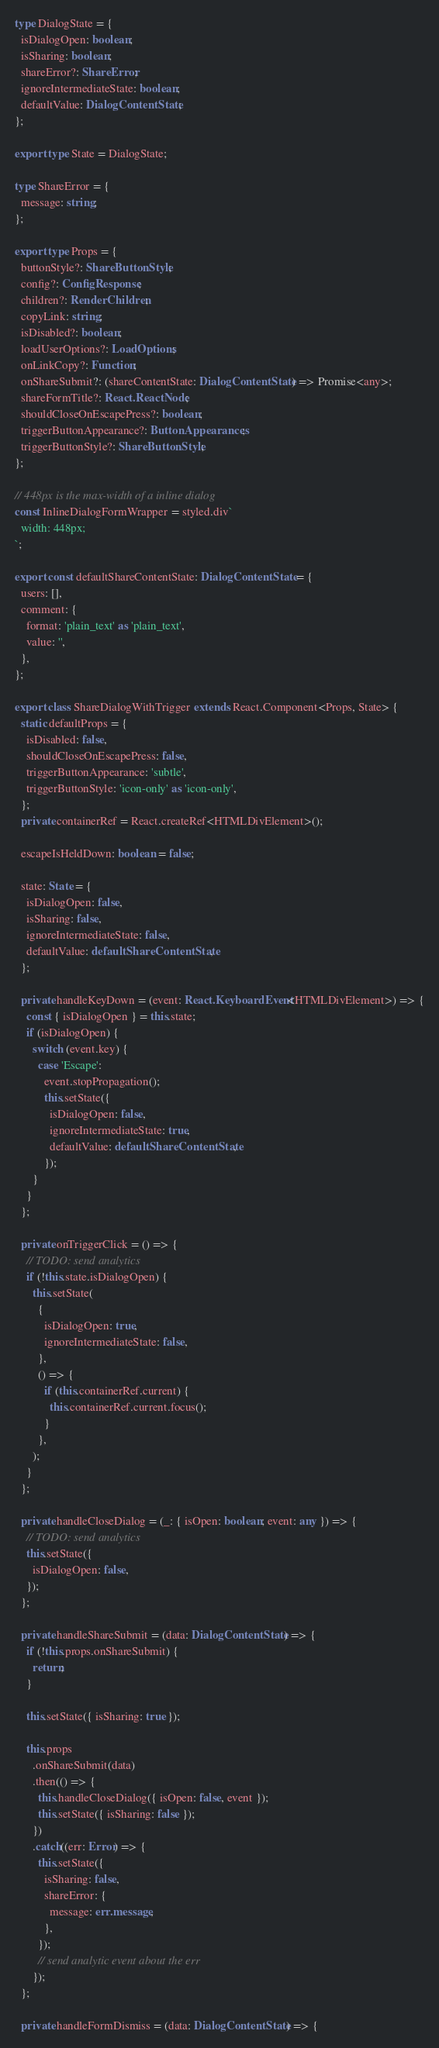Convert code to text. <code><loc_0><loc_0><loc_500><loc_500><_TypeScript_>
type DialogState = {
  isDialogOpen: boolean;
  isSharing: boolean;
  shareError?: ShareError;
  ignoreIntermediateState: boolean;
  defaultValue: DialogContentState;
};

export type State = DialogState;

type ShareError = {
  message: string;
};

export type Props = {
  buttonStyle?: ShareButtonStyle;
  config?: ConfigResponse;
  children?: RenderChildren;
  copyLink: string;
  isDisabled?: boolean;
  loadUserOptions?: LoadOptions;
  onLinkCopy?: Function;
  onShareSubmit?: (shareContentState: DialogContentState) => Promise<any>;
  shareFormTitle?: React.ReactNode;
  shouldCloseOnEscapePress?: boolean;
  triggerButtonAppearance?: ButtonAppearances;
  triggerButtonStyle?: ShareButtonStyle;
};

// 448px is the max-width of a inline dialog
const InlineDialogFormWrapper = styled.div`
  width: 448px;
`;

export const defaultShareContentState: DialogContentState = {
  users: [],
  comment: {
    format: 'plain_text' as 'plain_text',
    value: '',
  },
};

export class ShareDialogWithTrigger extends React.Component<Props, State> {
  static defaultProps = {
    isDisabled: false,
    shouldCloseOnEscapePress: false,
    triggerButtonAppearance: 'subtle',
    triggerButtonStyle: 'icon-only' as 'icon-only',
  };
  private containerRef = React.createRef<HTMLDivElement>();

  escapeIsHeldDown: boolean = false;

  state: State = {
    isDialogOpen: false,
    isSharing: false,
    ignoreIntermediateState: false,
    defaultValue: defaultShareContentState,
  };

  private handleKeyDown = (event: React.KeyboardEvent<HTMLDivElement>) => {
    const { isDialogOpen } = this.state;
    if (isDialogOpen) {
      switch (event.key) {
        case 'Escape':
          event.stopPropagation();
          this.setState({
            isDialogOpen: false,
            ignoreIntermediateState: true,
            defaultValue: defaultShareContentState,
          });
      }
    }
  };

  private onTriggerClick = () => {
    // TODO: send analytics
    if (!this.state.isDialogOpen) {
      this.setState(
        {
          isDialogOpen: true,
          ignoreIntermediateState: false,
        },
        () => {
          if (this.containerRef.current) {
            this.containerRef.current.focus();
          }
        },
      );
    }
  };

  private handleCloseDialog = (_: { isOpen: boolean; event: any }) => {
    // TODO: send analytics
    this.setState({
      isDialogOpen: false,
    });
  };

  private handleShareSubmit = (data: DialogContentState) => {
    if (!this.props.onShareSubmit) {
      return;
    }

    this.setState({ isSharing: true });

    this.props
      .onShareSubmit(data)
      .then(() => {
        this.handleCloseDialog({ isOpen: false, event });
        this.setState({ isSharing: false });
      })
      .catch((err: Error) => {
        this.setState({
          isSharing: false,
          shareError: {
            message: err.message,
          },
        });
        // send analytic event about the err
      });
  };

  private handleFormDismiss = (data: DialogContentState) => {</code> 